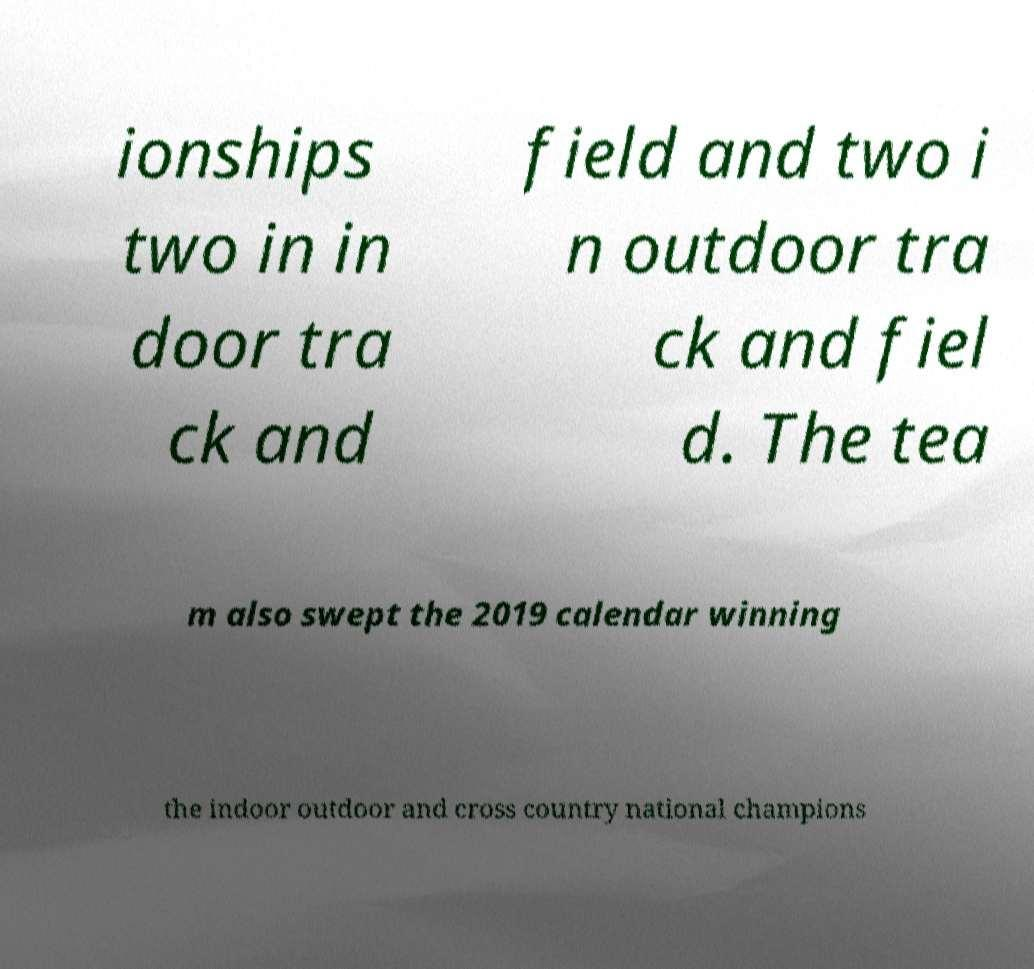Can you accurately transcribe the text from the provided image for me? ionships two in in door tra ck and field and two i n outdoor tra ck and fiel d. The tea m also swept the 2019 calendar winning the indoor outdoor and cross country national champions 